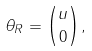<formula> <loc_0><loc_0><loc_500><loc_500>\theta _ { R } = { u \choose 0 } ,</formula> 